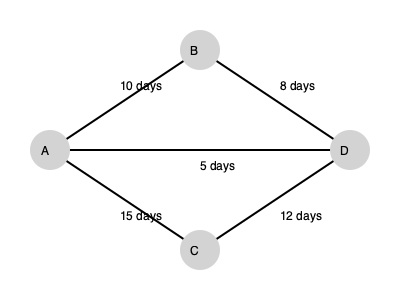As a project manager using the entrepreneur's software for workflow management, analyze the given network diagram and determine the critical path and the project duration using the Critical Path Method (CPM). To determine the critical path and project duration using CPM, we need to follow these steps:

1. Identify all possible paths:
   Path 1: A → B → D
   Path 2: A → C → D
   Path 3: A → D

2. Calculate the duration of each path:
   Path 1: A → B → D = 10 + 8 = 18 days
   Path 2: A → C → D = 15 + 12 = 27 days
   Path 3: A → D = 5 days

3. Identify the critical path:
   The critical path is the longest path through the network. In this case, it's Path 2: A → C → D, with a duration of 27 days.

4. Project duration:
   The project duration is equal to the length of the critical path, which is 27 days.

5. Slack time calculation:
   - Path 1 slack: 27 - 18 = 9 days
   - Path 3 slack: 27 - 5 = 22 days
   The critical path (Path 2) has zero slack by definition.

The critical path method helps identify the sequence of activities that directly affects the project completion time. Any delay in the critical path will result in a delay of the entire project.
Answer: Critical path: A → C → D; Project duration: 27 days 